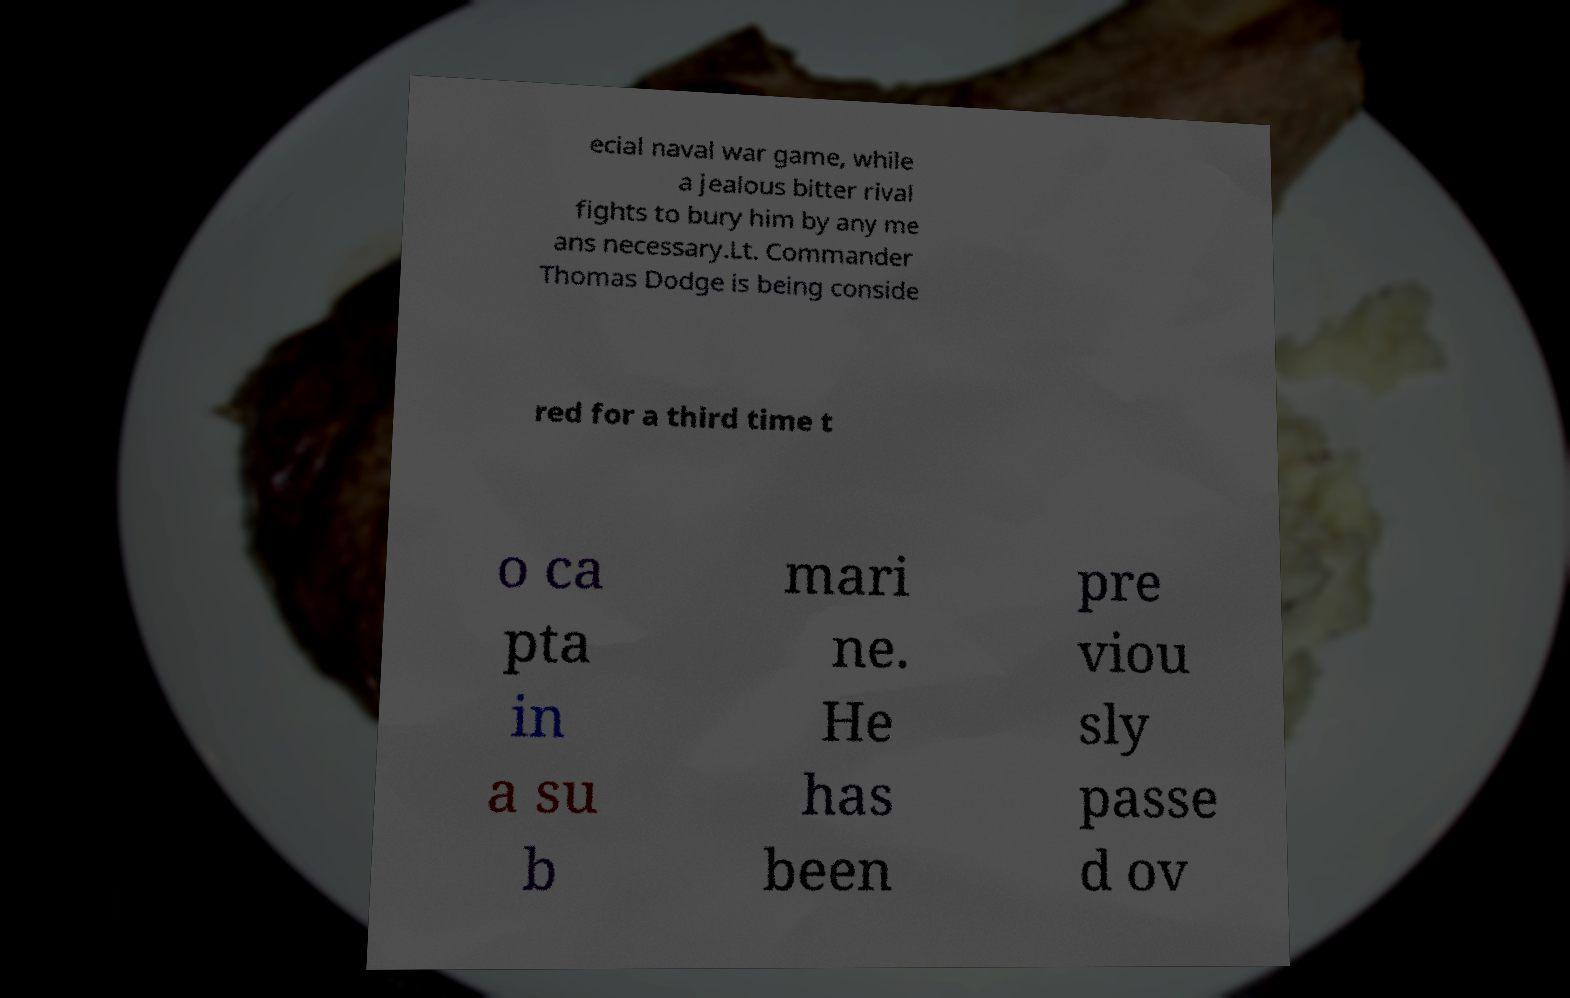Could you assist in decoding the text presented in this image and type it out clearly? ecial naval war game, while a jealous bitter rival fights to bury him by any me ans necessary.Lt. Commander Thomas Dodge is being conside red for a third time t o ca pta in a su b mari ne. He has been pre viou sly passe d ov 